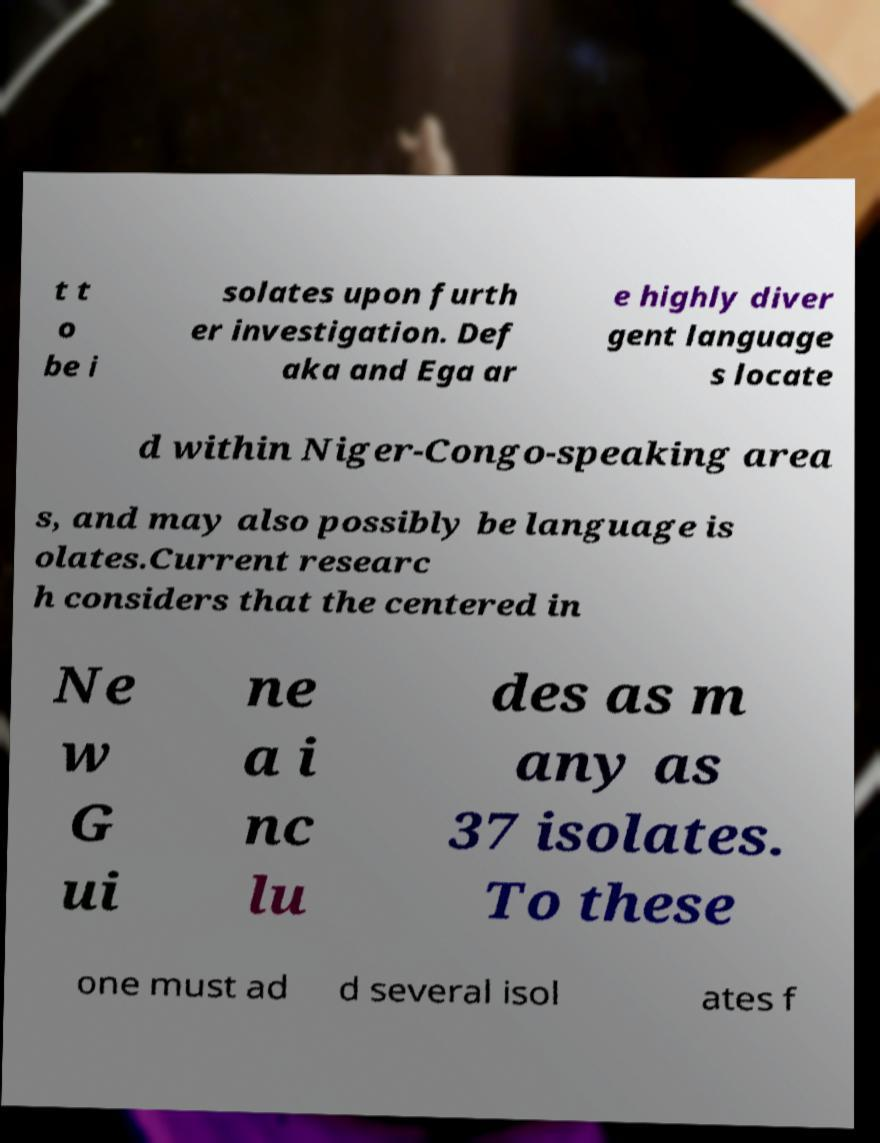Can you accurately transcribe the text from the provided image for me? t t o be i solates upon furth er investigation. Def aka and Ega ar e highly diver gent language s locate d within Niger-Congo-speaking area s, and may also possibly be language is olates.Current researc h considers that the centered in Ne w G ui ne a i nc lu des as m any as 37 isolates. To these one must ad d several isol ates f 